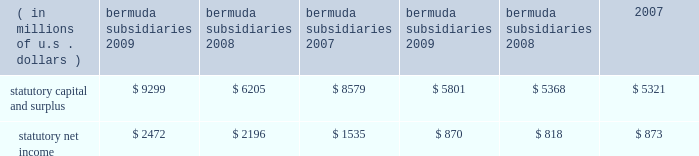N o t e s t o t h e c o n s o l i d a t e d f i n a n c i a l s t a t e m e n t s ( continued ) ace limited and subsidiaries 20 .
Statutory financial information the company 2019s insurance and reinsurance subsidiaries are subject to insurance laws and regulations in the jurisdictions in which they operate .
These regulations include restrictions that limit the amount of dividends or other distributions , such as loans or cash advances , available to shareholders without prior approval of the insurance regulatory authorities .
There are no statutory restrictions on the payment of dividends from retained earnings by any of the bermuda subsidiaries as the minimum statutory capital and surplus requirements are satisfied by the share capital and additional paid-in capital of each of the bermuda subsidiaries .
The company 2019s u.s .
Subsidiaries file financial statements prepared in accordance with statutory accounting practices prescribed or permitted by insurance regulators .
Statutory accounting differs from gaap in the reporting of certain reinsurance contracts , investments , subsidiaries , acquis- ition expenses , fixed assets , deferred income taxes , and certain other items .
The statutory capital and surplus of the u.s .
Subsidiaries met regulatory requirements for 2009 , 2008 , and 2007 .
The amount of dividends available to be paid in 2010 , without prior approval from the state insurance departments , totals $ 733 million .
The combined statutory capital and surplus and statutory net income of the bermuda and u.s .
Subsidiaries as at and for the years ended december 31 , 2009 , 2008 , and 2007 , are as follows: .
As permitted by the restructuring discussed previously in note 7 , certain of the company 2019s u.s .
Subsidiaries discount certain a&e liabilities , which increased statutory capital and surplus by approximately $ 215 million , $ 211 million , and $ 140 million at december 31 , 2009 , 2008 , and 2007 , respectively .
The company 2019s international subsidiaries prepare statutory financial statements based on local laws and regulations .
Some jurisdictions impose complex regulatory requirements on insurance companies while other jurisdictions impose fewer requirements .
In some countries , the company must obtain licenses issued by governmental authorities to conduct local insurance business .
These licenses may be subject to reserves and minimum capital and solvency tests .
Jurisdictions may impose fines , censure , and/or criminal sanctions for violation of regulatory requirements .
21 .
Information provided in connection with outstanding debt of subsidiaries the following tables present condensed consolidating financial information at december 31 , 2009 , and december 31 , 2008 , and for the years ended december 31 , 2009 , 2008 , and 2007 , for ace limited ( the parent guarantor ) and its 201csubsidiary issuer 201d , ace ina holdings , inc .
The subsidiary issuer is an indirect 100 percent-owned subsidiary of the parent guarantor .
Investments in subsidiaries are accounted for by the parent guarantor under the equity method for purposes of the supplemental consolidating presentation .
Earnings of subsidiaries are reflected in the parent guarantor 2019s investment accounts and earnings .
The parent guarantor fully and unconditionally guarantees certain of the debt of the subsidiary issuer. .
What is the income to capital ratio for bermuda subsidiaries in 2009? 
Computations: (2472 / 9299)
Answer: 0.26584. 